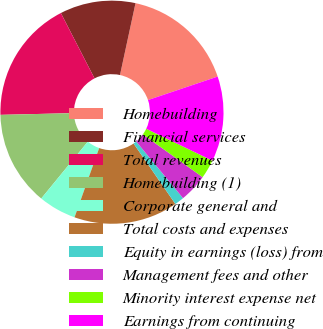Convert chart. <chart><loc_0><loc_0><loc_500><loc_500><pie_chart><fcel>Homebuilding<fcel>Financial services<fcel>Total revenues<fcel>Homebuilding (1)<fcel>Corporate general and<fcel>Total costs and expenses<fcel>Equity in earnings (loss) from<fcel>Management fees and other<fcel>Minority interest expense net<fcel>Earnings from continuing<nl><fcel>16.44%<fcel>10.96%<fcel>17.81%<fcel>13.7%<fcel>5.48%<fcel>15.07%<fcel>1.37%<fcel>4.11%<fcel>2.74%<fcel>12.33%<nl></chart> 